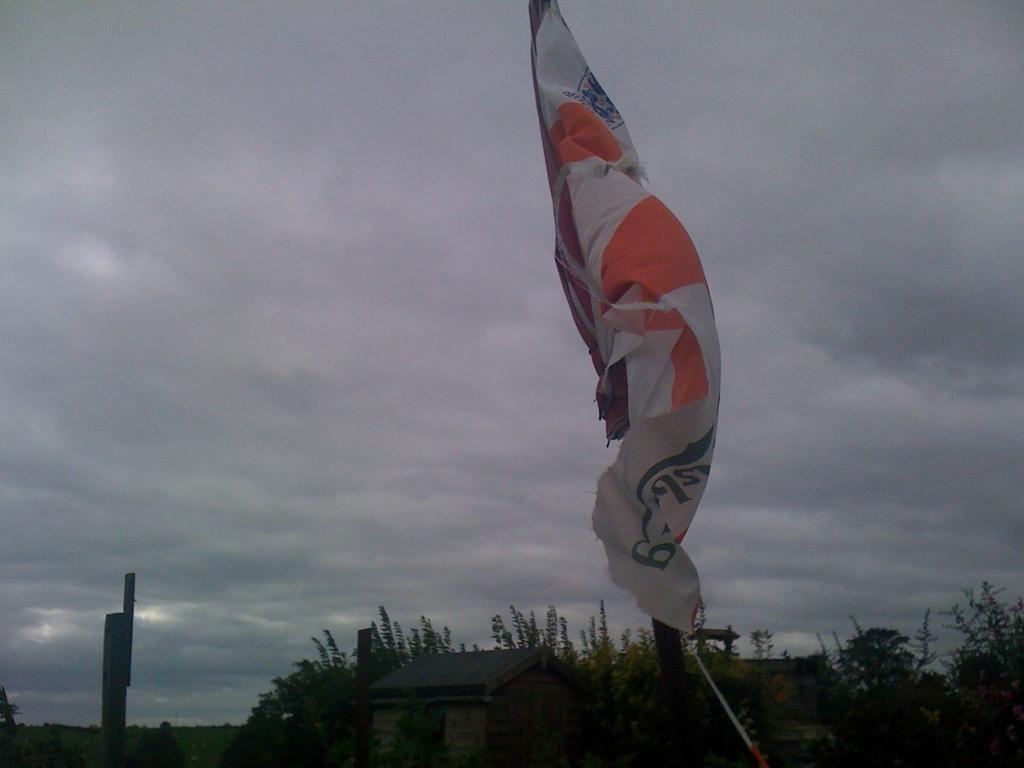In one or two sentences, can you explain what this image depicts? In this picture we can see white flag in the front. Behind there is a small shed house and some trees. On the top we can see the cloudy sky. 